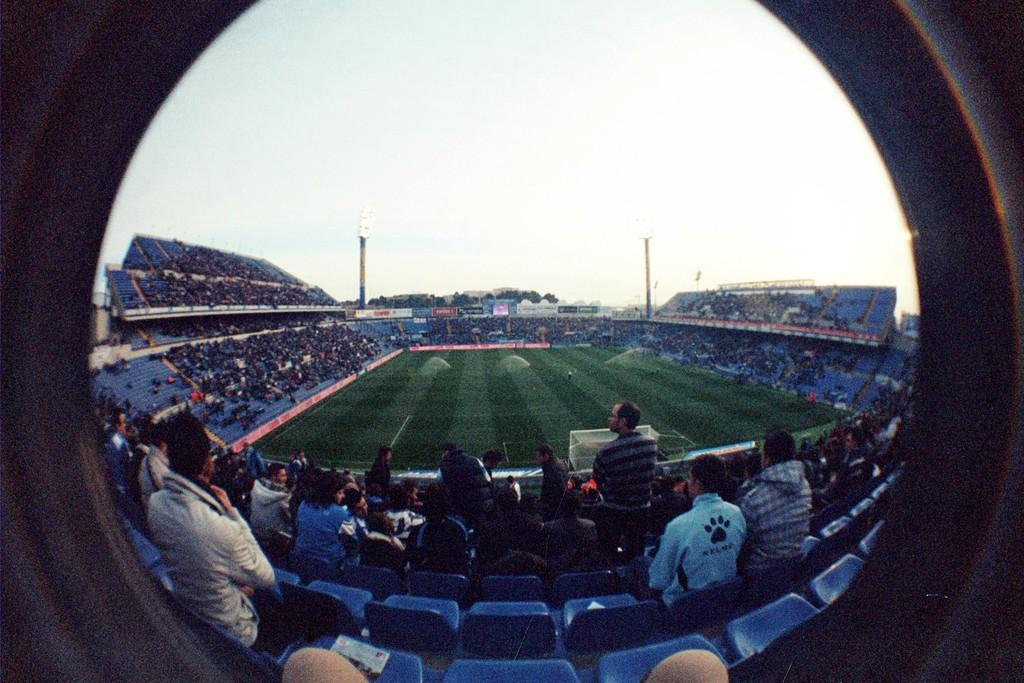Who can be seen in the image? There are spectators in the image. What type of location is depicted in the image? There is a sports ground in the image. What feature is present to provide lighting during night games? Flood lights are visible in the image. What type of natural elements can be seen in the image? There are trees in the image. What is visible in the background of the image? The sky is visible in the image. What type of kite can be seen flying in the image? There is no kite present in the image; it features spectators at a sports ground with flood lights and trees. How do the acoustics of the sports ground affect the spectators' experience in the image? The provided facts do not mention anything about the acoustics of the sports ground, so it is not possible to determine how they affect the spectators' experience from the image alone. 